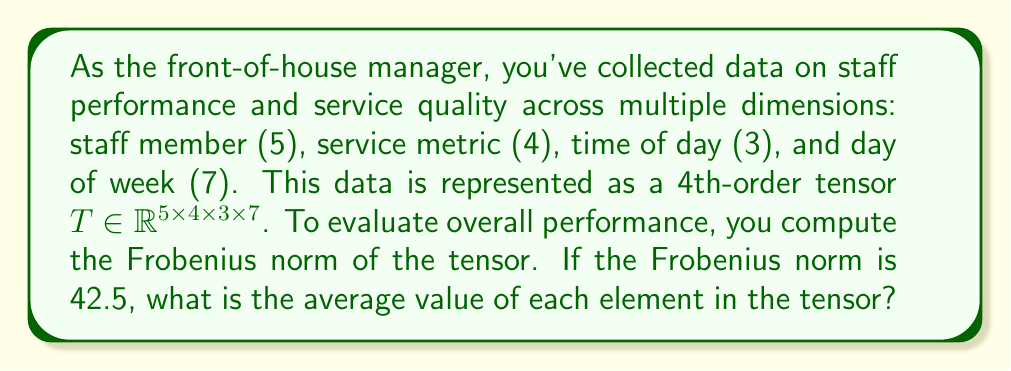Solve this math problem. Let's approach this step-by-step:

1) The Frobenius norm of a tensor $T$ is defined as the square root of the sum of the squares of all its elements:

   $$\|T\|_F = \sqrt{\sum_{i,j,k,l} |t_{ijkl}|^2}$$

2) We're given that the Frobenius norm is 42.5:

   $$\|T\|_F = 42.5$$

3) Squaring both sides:

   $$\sum_{i,j,k,l} |t_{ijkl}|^2 = 42.5^2 = 1806.25$$

4) The total number of elements in the tensor is the product of its dimensions:

   $$5 \times 4 \times 3 \times 7 = 420$$

5) Let $\mu$ be the average value of each element. Then:

   $$420 \mu^2 = 1806.25$$

6) Solving for $\mu$:

   $$\mu^2 = \frac{1806.25}{420} = 4.3$$
   
   $$\mu = \sqrt{4.3} \approx 2.0736$$

Therefore, the average value of each element in the tensor is approximately 2.0736.
Answer: $2.0736$ 